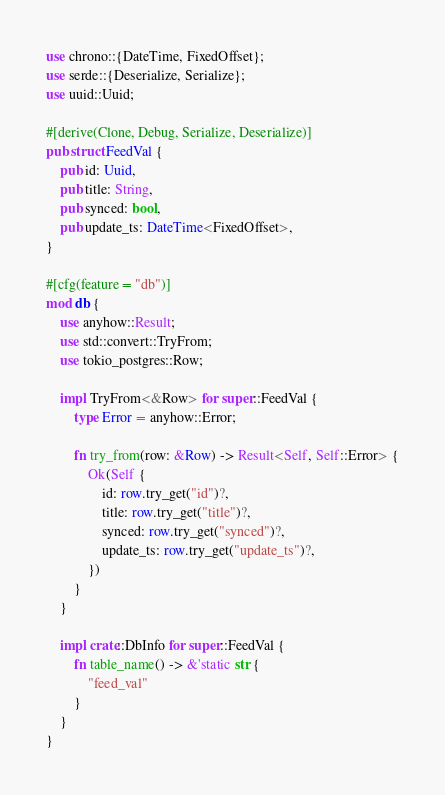<code> <loc_0><loc_0><loc_500><loc_500><_Rust_>use chrono::{DateTime, FixedOffset};
use serde::{Deserialize, Serialize};
use uuid::Uuid;

#[derive(Clone, Debug, Serialize, Deserialize)]
pub struct FeedVal {
    pub id: Uuid,
    pub title: String,
    pub synced: bool,
    pub update_ts: DateTime<FixedOffset>,
}

#[cfg(feature = "db")]
mod db {
    use anyhow::Result;
    use std::convert::TryFrom;
    use tokio_postgres::Row;

    impl TryFrom<&Row> for super::FeedVal {
        type Error = anyhow::Error;

        fn try_from(row: &Row) -> Result<Self, Self::Error> {
            Ok(Self {
                id: row.try_get("id")?,
                title: row.try_get("title")?,
                synced: row.try_get("synced")?,
                update_ts: row.try_get("update_ts")?,
            })
        }
    }

    impl crate::DbInfo for super::FeedVal {
        fn table_name() -> &'static str {
            "feed_val"
        }
    }
}
</code> 